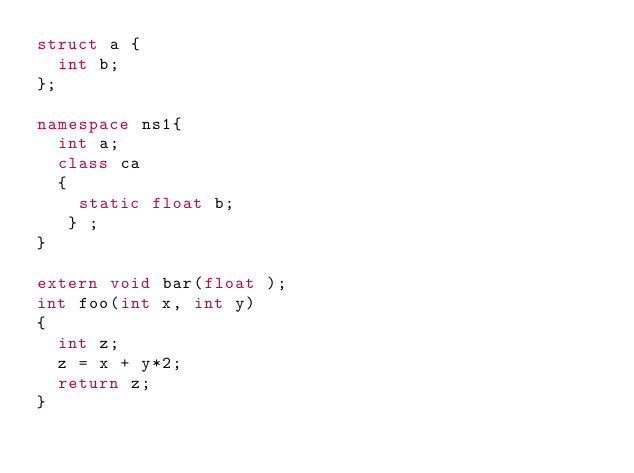<code> <loc_0><loc_0><loc_500><loc_500><_C++_>struct a {
  int b;  
};

namespace ns1{
  int a; 
  class ca 
  {
    static float b;
   } ;
}

extern void bar(float );
int foo(int x, int y)
{
  int z;
  z = x + y*2;
  return z;
}
</code> 